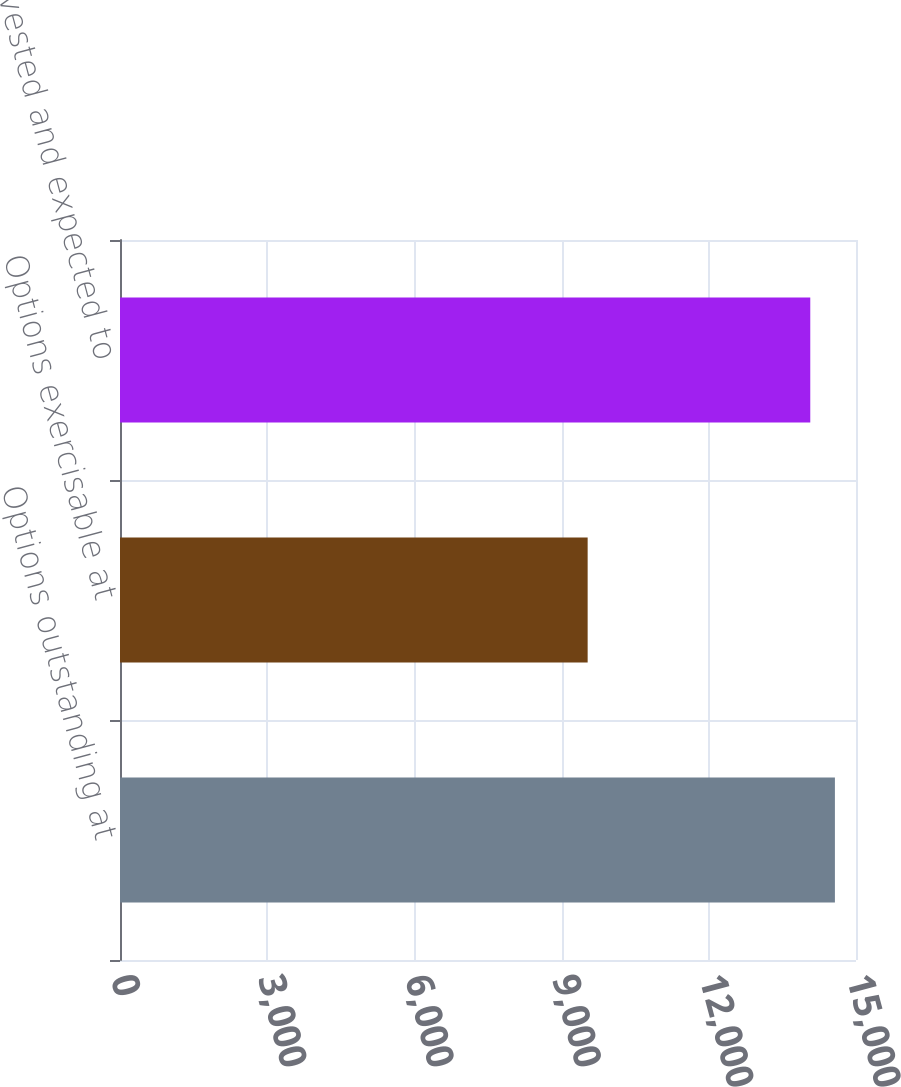<chart> <loc_0><loc_0><loc_500><loc_500><bar_chart><fcel>Options outstanding at<fcel>Options exercisable at<fcel>Options vested and expected to<nl><fcel>14570.2<fcel>9531<fcel>14068<nl></chart> 